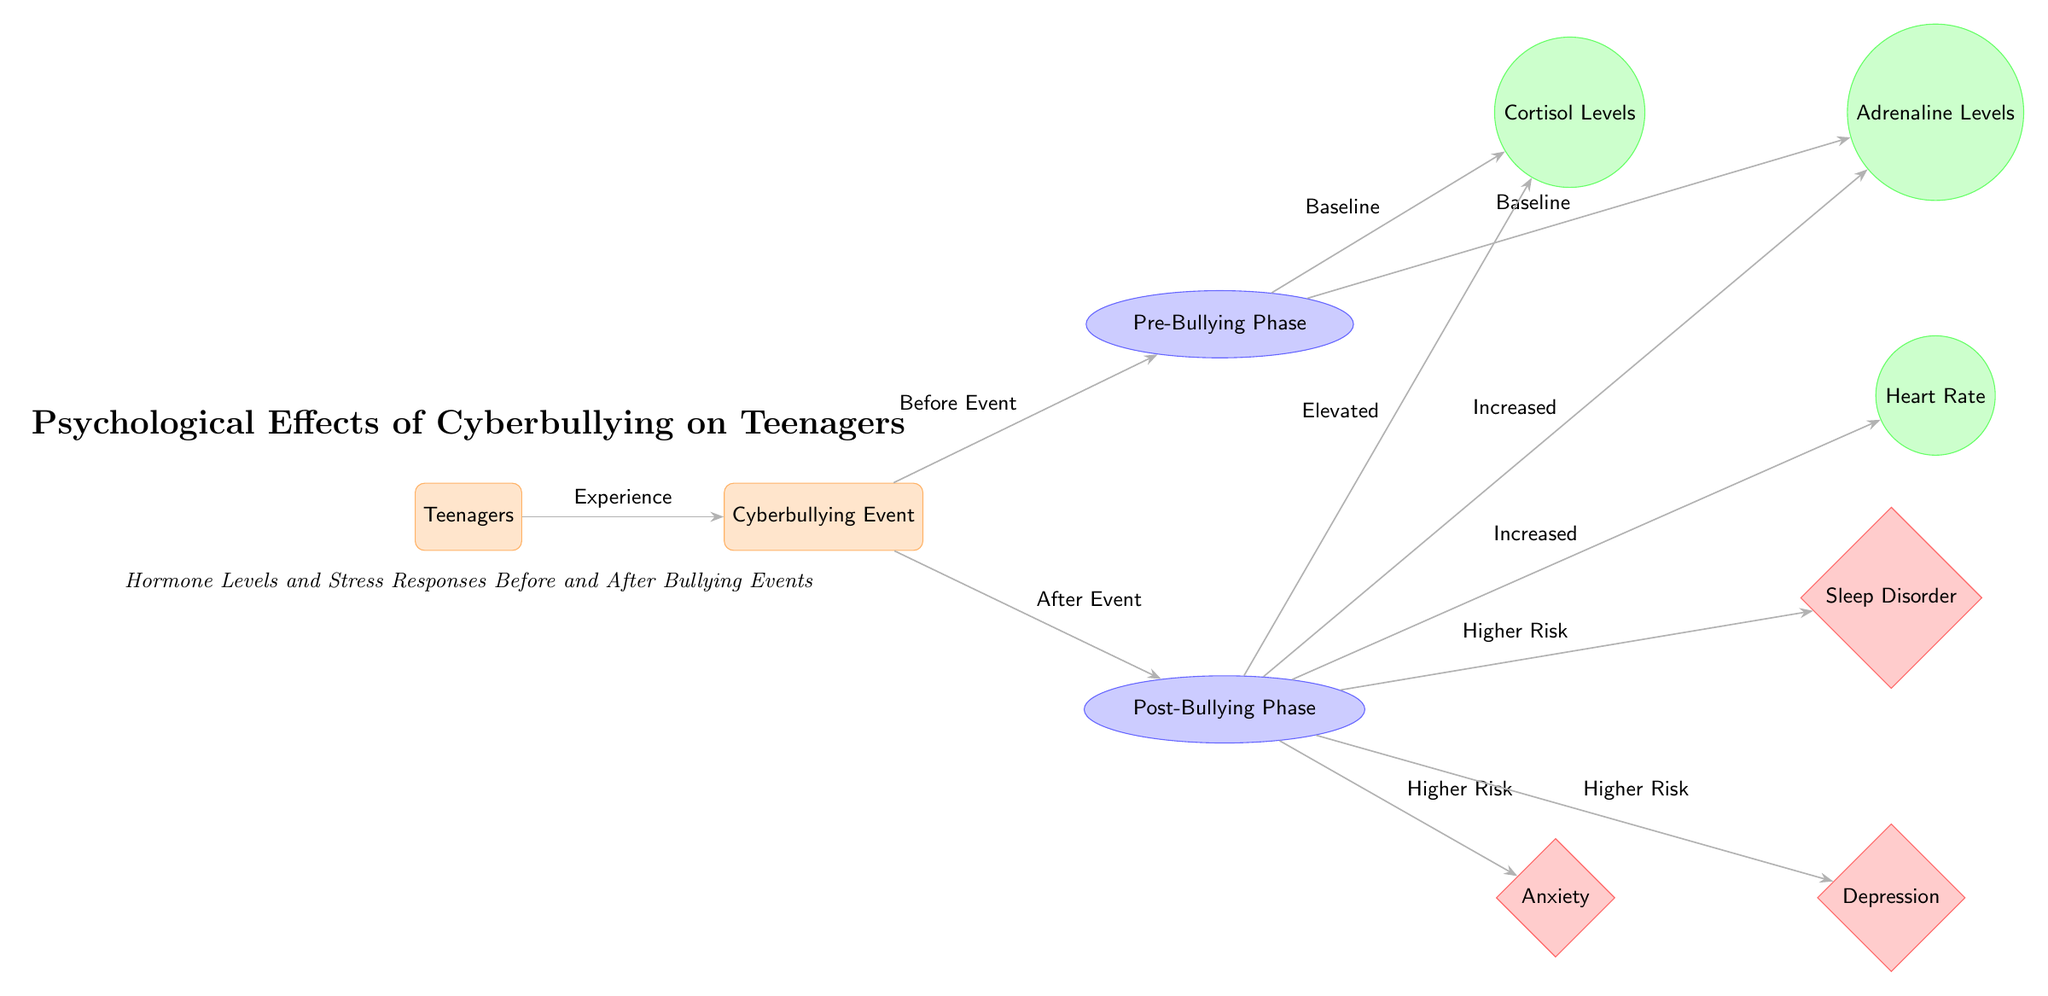What event do the teenagers experience? The diagram indicates that the teenagers experience a "Cyberbullying Event." This is highlighted as the main event in the flow, connecting the teenagers and the subsequent phases.
Answer: Cyberbullying Event What are the two phases depicted in the diagram? The diagram shows two phases: "Pre-Bullying Phase" and "Post-Bullying Phase." These phases represent the psychological and physiological states before and after the bullying event.
Answer: Pre-Bullying Phase, Post-Bullying Phase How does cortisol level change after the bullying event? The diagram indicates that cortisol levels are at a "Baseline" state in the pre-bullying phase and "Elevated" after the bullying event, showing a direct impact of the event on hormone levels.
Answer: Elevated Which psychological effects increase after the cyberbullying event? According to the diagram, the psychological effects that increase after the bullying event include "Anxiety," "Depression," and "Sleep Disorder." Each of these effects is connected to the post-bullying phase, indicating a heightened risk following the event.
Answer: Anxiety, Depression, Sleep Disorder What is the relationship between the post-bullying phase and heart rate? The diagram depicts that during the post-bullying phase, the heart rate is labeled as "Increased." This indicates that the bullying has a direct effect on the heart rate of the teenagers.
Answer: Increased Why are cortisol and adrenaline levels elevated after the cyberbullying event? The diagram illustrates that both cortisol and adrenaline levels are affected by the bullying event, with cortisol levels being described as "Elevated" and adrenaline levels as "Increased" in the post-bullying phase, signifying a physiological stress response.
Answer: Physiological stress response Which of the psychological effects has the highest perceived risk stated in the diagram? The diagram connects the post-bullying phase to three psychological effects, all labeled with "Higher Risk." Evaluating the context, "Anxiety" is often cited as having a profound immediate impact in similar studies, but the diagram does not distinguish between them. All are considered equally heightened, but "Anxiety" is often prioritized in discourse.
Answer: Higher Risk What is the role of teenagers in the diagram? Teenagers act as the initial node in the diagram, representing the demographic affected by the cyberbullying event. Their experience serves as the primary focus from which the subsequent effects are derived.
Answer: Affected demographic 